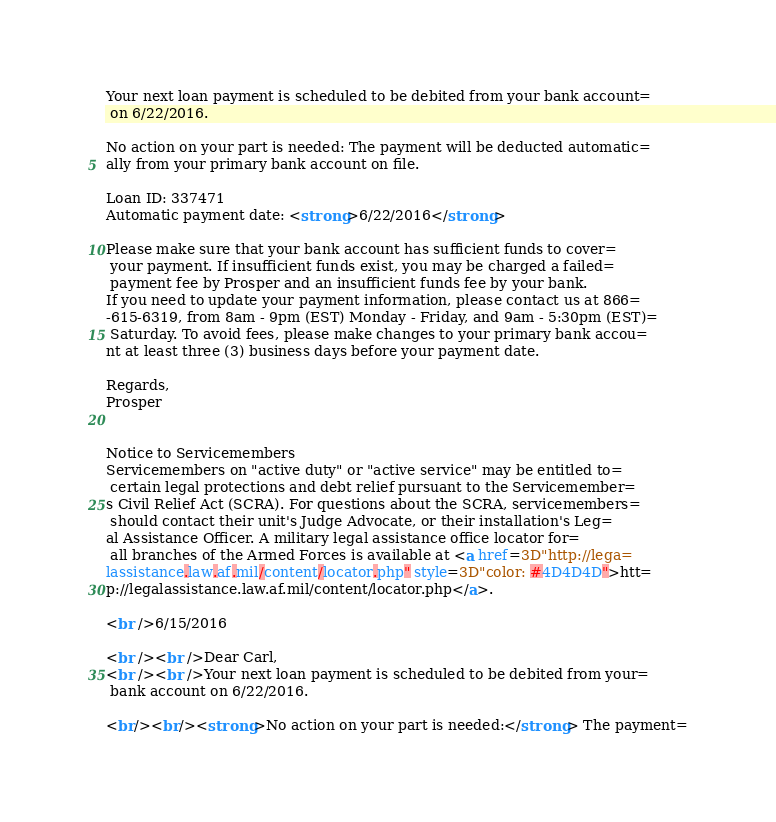<code> <loc_0><loc_0><loc_500><loc_500><_HTML_>Your next loan payment is scheduled to be debited from your bank account=
 on 6/22/2016.

No action on your part is needed: The payment will be deducted automatic=
ally from your primary bank account on file.

Loan ID: 337471
Automatic payment date: <strong>6/22/2016</strong>

Please make sure that your bank account has sufficient funds to cover=
 your payment. If insufficient funds exist, you may be charged a failed=
 payment fee by Prosper and an insufficient funds fee by your bank.
If you need to update your payment information, please contact us at 866=
-615-6319, from 8am - 9pm (EST) Monday - Friday, and 9am - 5:30pm (EST)=
 Saturday. To avoid fees, please make changes to your primary bank accou=
nt at least three (3) business days before your payment date.

Regards,
Prosper


Notice to Servicemembers
Servicemembers on "active duty" or "active service" may be entitled to=
 certain legal protections and debt relief pursuant to the Servicemember=
s Civil Relief Act (SCRA). For questions about the SCRA, servicemembers=
 should contact their unit's Judge Advocate, or their installation's Leg=
al Assistance Officer. A military legal assistance office locator for=
 all branches of the Armed Forces is available at <a href=3D"http://lega=
lassistance.law.af.mil/content/locator.php" style=3D"color: #4D4D4D">htt=
p://legalassistance.law.af.mil/content/locator.php</a>.

<br />6/15/2016

<br /><br />Dear Carl,
<br /><br />Your next loan payment is scheduled to be debited from your=
 bank account on 6/22/2016.

<br/><br/><strong>No action on your part is needed:</strong> The payment=</code> 